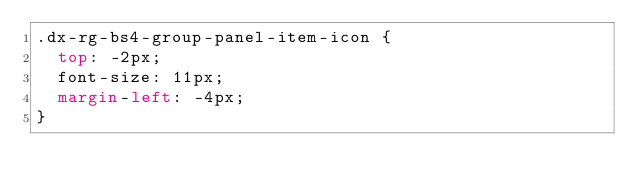<code> <loc_0><loc_0><loc_500><loc_500><_CSS_>.dx-rg-bs4-group-panel-item-icon {
  top: -2px;
  font-size: 11px;
  margin-left: -4px;
}
</code> 